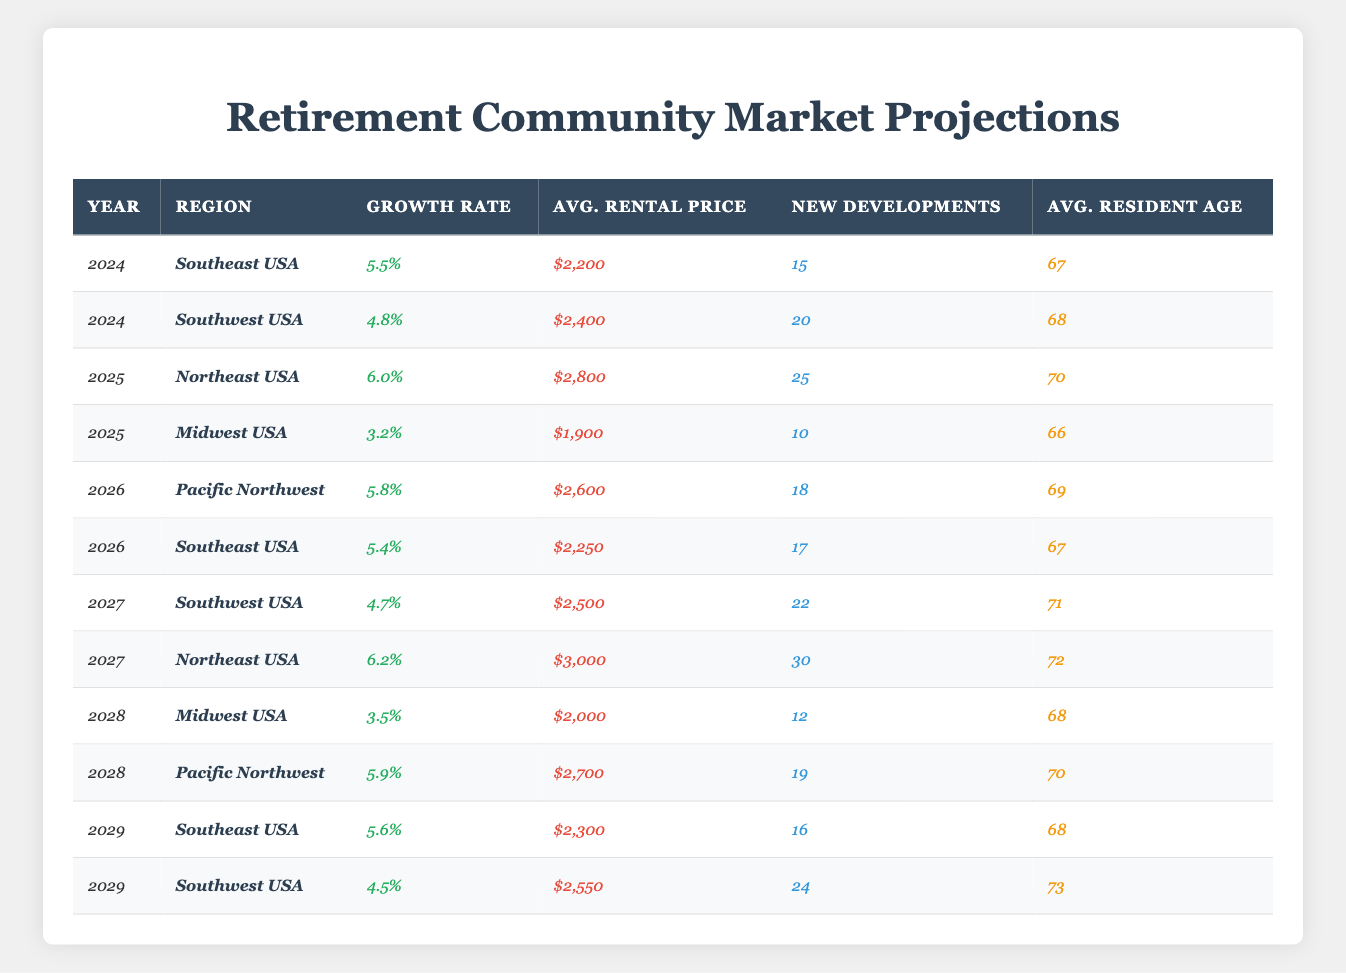What is the projected growth rate for retirement communities in the Southeast USA in 2024? According to the table, the projected growth rate for the Southeast USA in 2024 is listed as 5.5%.
Answer: 5.5% How many new developments are planned in the Southwest USA for 2027? From the table, the number of new developments planned in the Southwest USA for 2027 is 22.
Answer: 22 What is the average rental price for retirement communities in the Northeast USA in 2025? The table indicates that the average rental price for retirement communities in the Northeast USA in 2025 is $2,800.
Answer: $2,800 Which region has the highest projected growth rate in 2027? By comparing the growth rates for 2027 from the table, the Northeast USA has the highest projected growth rate of 6.2%.
Answer: Northeast USA What is the difference in average rental price between the Midwest USA in 2025 and 2028? The average rental price in 2025 for the Midwest USA is $1,900, while in 2028 it is $2,000. The difference is $2,000 - $1,900 = $100.
Answer: $100 Is the average age of residents in the Southwest USA increasing or decreasing from 2024 to 2027? In 2024, the average age of residents in the Southwest USA is 68, and in 2027, it is 71, which shows an increase of 3 years.
Answer: Increasing How many new developments are planned over the years from 2024 to 2026 in the Southeast USA? In 2024, there are 15 new developments, in 2026 there are 17 new developments. The total for these years is 15 + 17 = 32.
Answer: 32 Which region has the highest average rental price in 2029 among the listed regions? The table shows that in 2029, the average rental price in the Southwest USA is $2,550, while in Southeast USA, it is $2,300. The highest is the Southwest USA.
Answer: Southwest USA Calculate the average rental price for the Pacific Northwest over 2026 and 2028. The rental price for the Pacific Northwest in 2026 is $2,600 and in 2028 it is $2,700. The average is ($2,600 + $2,700) / 2 = $2,650.
Answer: $2,650 What trend can be observed for new developments in the Southeast USA from 2024 to 2029? Analyzing the numbers from the table, new developments in the Southeast USA are 15 in 2024, 17 in 2026, and 16 in 2029, indicating fluctuating levels with a slight decrease from 17 to 16.
Answer: Fluctuating levels with a slight decrease 